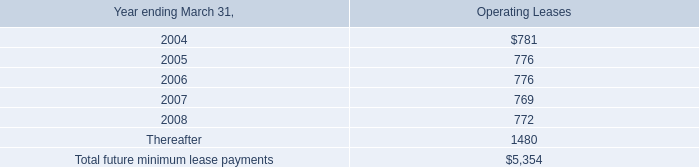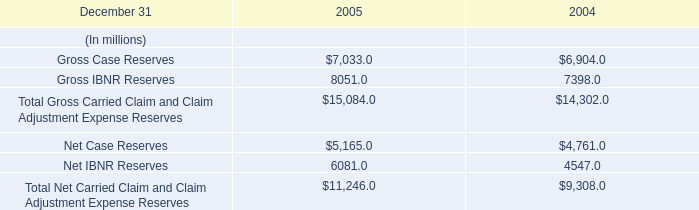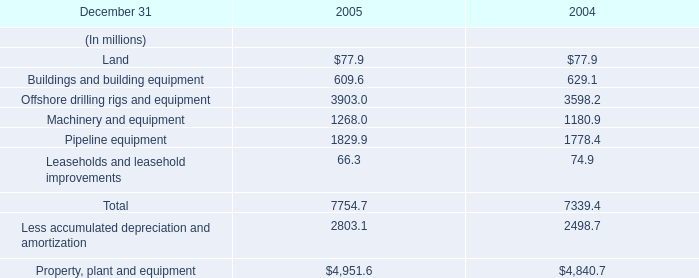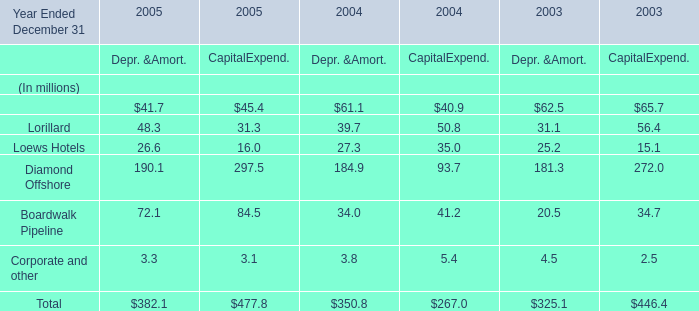What is the total amount of Net Case Reserves of 2004, Machinery and equipment of 2005, and Gross IBNR Reserves of 2004 ? 
Computations: ((4761.0 + 1268.0) + 7398.0)
Answer: 13427.0. 